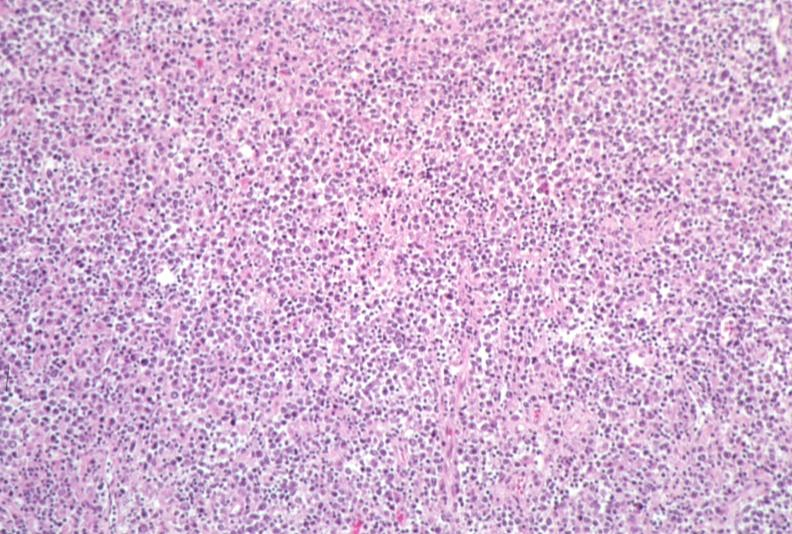does this image show lymph node, lymphoma?
Answer the question using a single word or phrase. Yes 